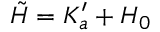Convert formula to latex. <formula><loc_0><loc_0><loc_500><loc_500>\tilde { H } = K _ { a } ^ { \prime } + H _ { 0 }</formula> 